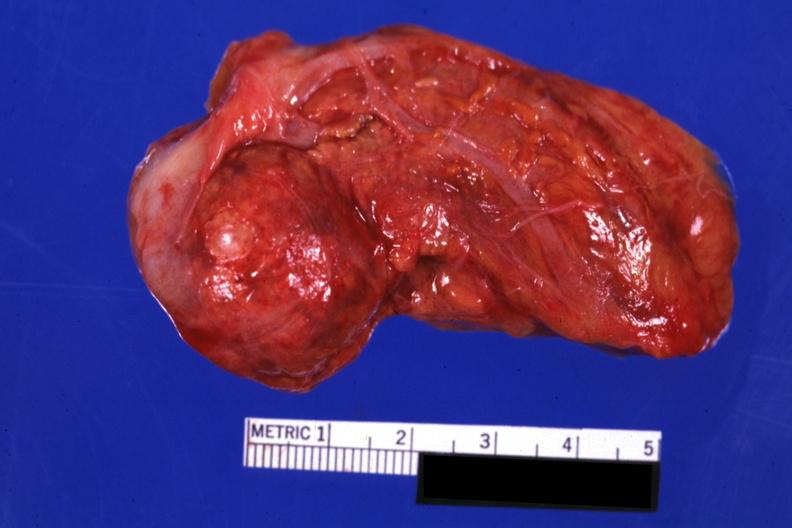how does this image show intact gland?
Answer the question using a single word or phrase. With obvious nodule 